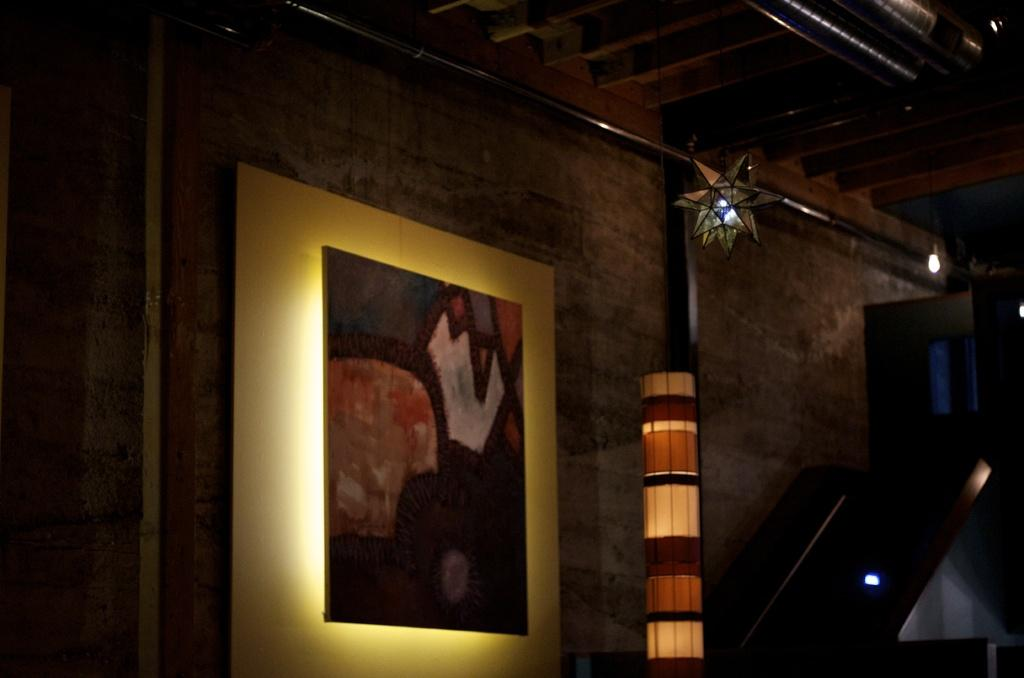What is attached to the wall in the image? There is a board on the wall in the image. What type of lighting is present in the image? There is a lamp and lights in the image. Can you describe the decorative item in the image? Unfortunately, the provided facts do not specify the nature of the decorative item. How many mice are running around the board in the image? There are no mice present in the image. What decision is the cook making in the image? There is no cook or decision-making process depicted in the image. 